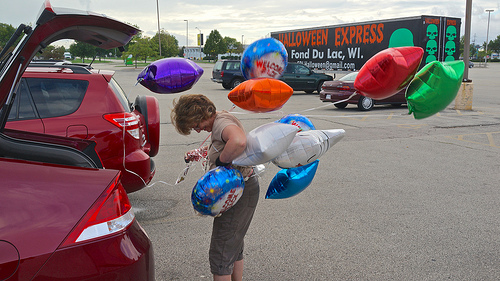<image>
Is there a balloon under the truck? No. The balloon is not positioned under the truck. The vertical relationship between these objects is different. 